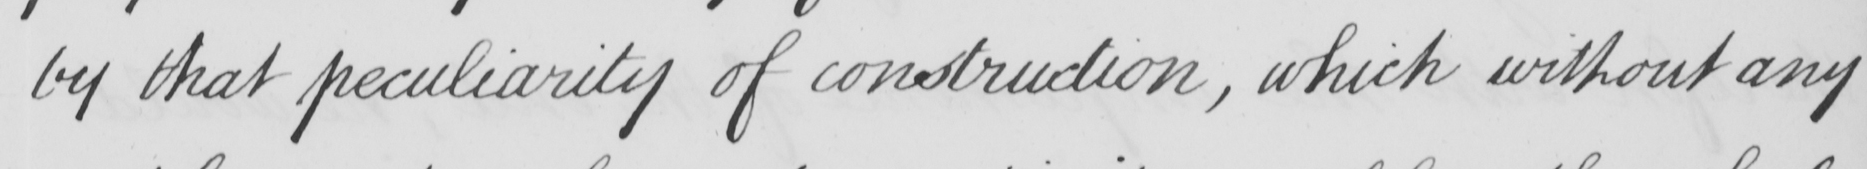Please transcribe the handwritten text in this image. by that peculiarity of construction , which without any 